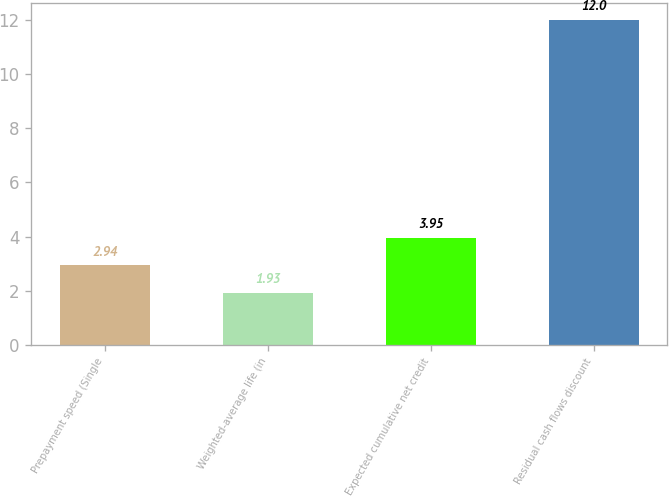Convert chart. <chart><loc_0><loc_0><loc_500><loc_500><bar_chart><fcel>Prepayment speed (Single<fcel>Weighted-average life (in<fcel>Expected cumulative net credit<fcel>Residual cash flows discount<nl><fcel>2.94<fcel>1.93<fcel>3.95<fcel>12<nl></chart> 